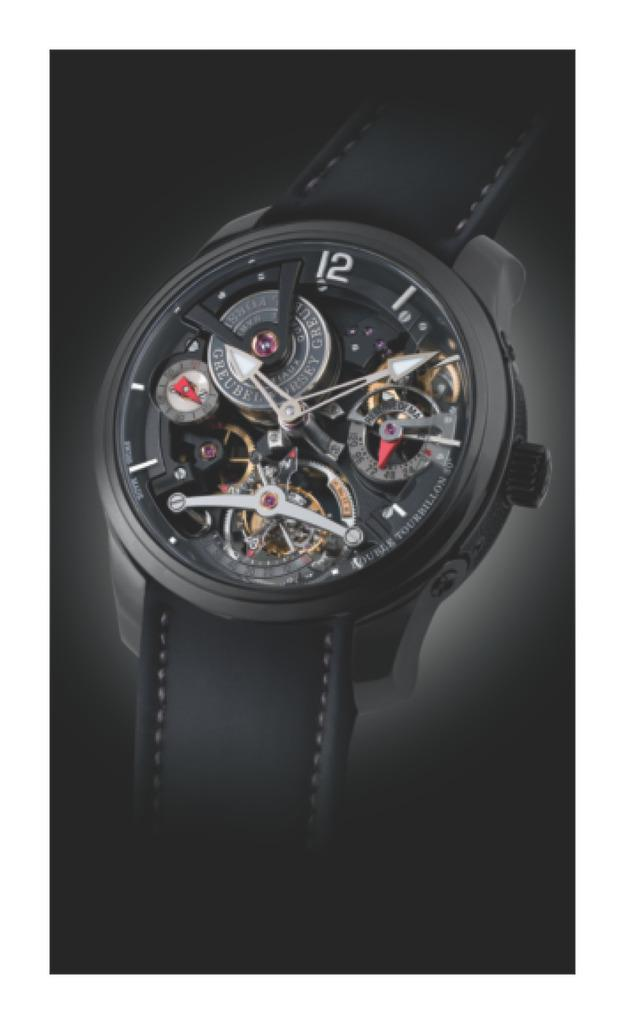<image>
Provide a brief description of the given image. black watch that shows the inner workings and has number 12 at top 